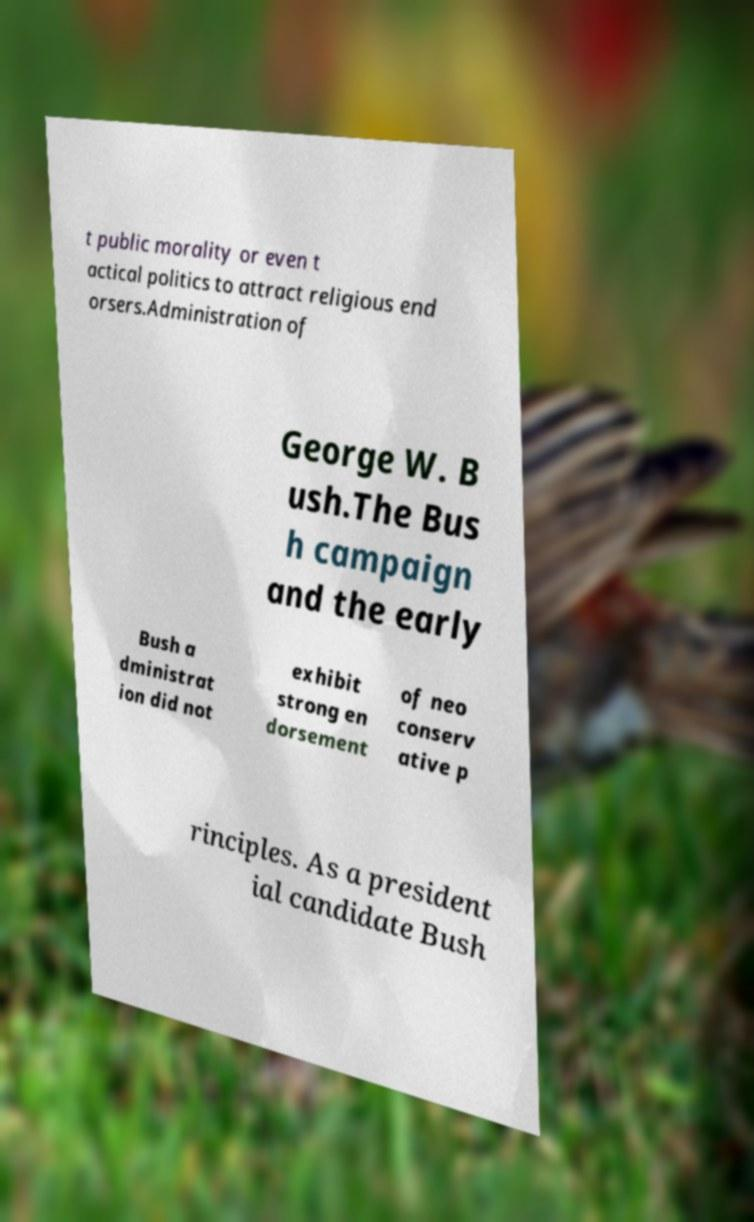What messages or text are displayed in this image? I need them in a readable, typed format. t public morality or even t actical politics to attract religious end orsers.Administration of George W. B ush.The Bus h campaign and the early Bush a dministrat ion did not exhibit strong en dorsement of neo conserv ative p rinciples. As a president ial candidate Bush 